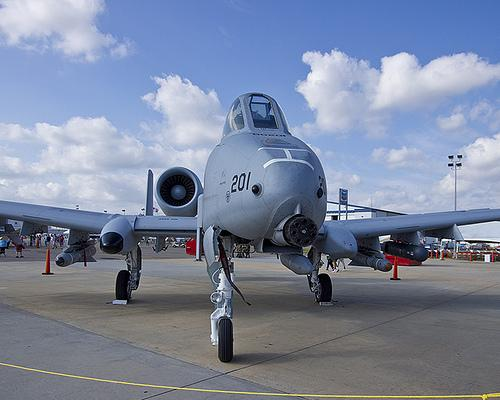Mention the weapons attached to the aircraft. There are missiles located under the wings and a large gun on the front of the plane. Analyze the object interaction of the aircraft with its surrounding environment. The aircraft is stationary on the tarmac, surrounded by orange cones, with tires on the ground, and missiles attached under its wings. Describe the setting and time of the day in which the photo was taken. The photo was taken outdoors during daytime with a blue sky and white clouds. Determine any visible image sentiment or mood. The image has a neutral sentiment with a focus on the display of an aircraft in its natural environment. Identify distant details in the image such as people and objects in the background. There are people, a light pole, and orange-colored cones visible in the background of the image. Identify the type of aircraft in the image and where it is located. A gray A10 Warthog is on the tarmac at an airport. Describe the placement and appearance of the aircraft's cockpit. The glass cockpit of the plane is situated towards the front, with a width of 67 and height of 67. Comment on the visibility of the wheels and the landing gear in the image. There are black tires visible on the landing gear, at the front, left, and right side of the plane. Count every visible tire on the tarmac and provide their locations. There are 3 black tires on the tarmac, located at front, left, and right wheel of the plane. List the markings and colors on the aircraft. There are white lines on the nose and wings of the aircraft, and the number 201 on its side. 